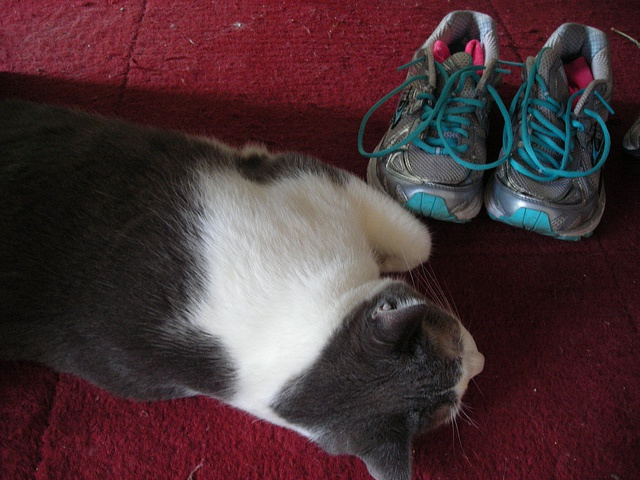Describe the objects in this image and their specific colors. I can see a cat in brown, black, lightgray, darkgray, and gray tones in this image. 